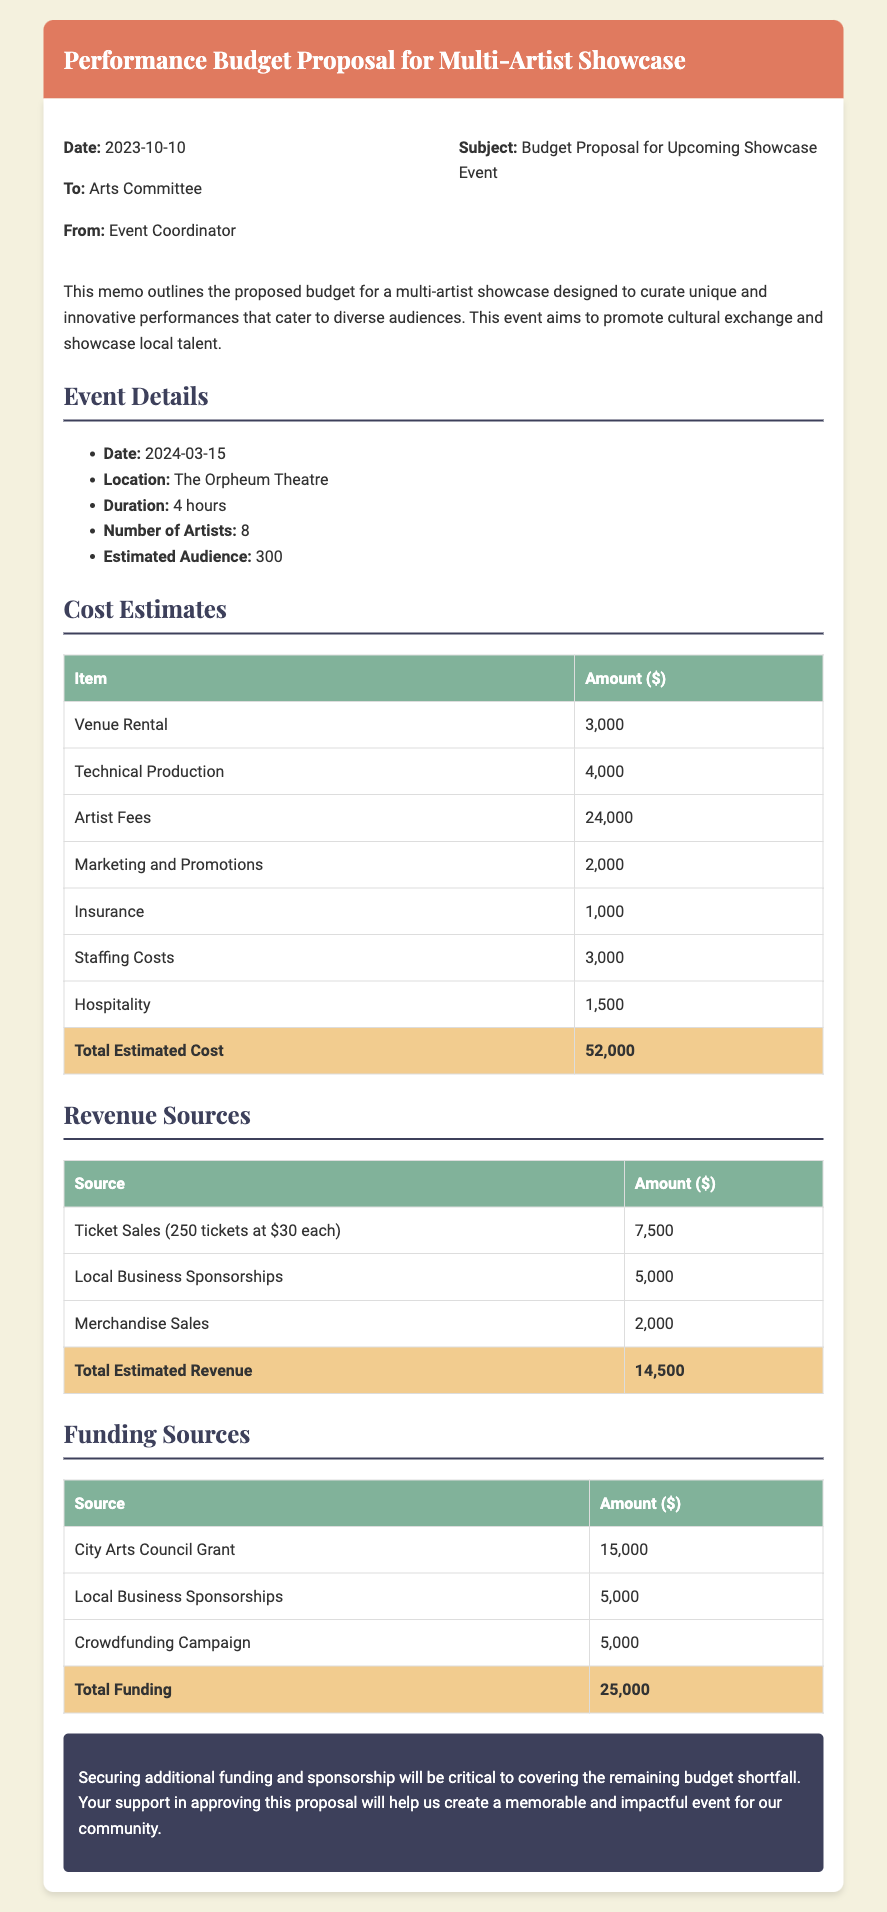what is the date of the event? The date of the event is explicitly listed in the document under the event details section.
Answer: 2024-03-15 how many artists are participating? The number of artists is mentioned in the event details as part of the showcase information.
Answer: 8 what is the total estimated cost? The total estimated cost is provided in the cost estimates table at the bottom of the section.
Answer: 52,000 what is the amount from ticket sales? The amount from ticket sales can be found in the revenue sources table, specifying ticket sales income.
Answer: 7,500 what is the total funding? The total funding is summarized in the funding sources table, giving a clear total amount for funding.
Answer: 25,000 how much is allocated for artist fees? The artist fees are specifically listed in the cost estimates table among the expense items.
Answer: 24,000 what is the main purpose of the event? The purpose of the event is described in the introductory paragraph of the memo.
Answer: Promote cultural exchange what is the venue for the event? The venue is mentioned in the event details section and specifies the location for the showcase.
Answer: The Orpheum Theatre what is the estimated audience size? The estimated audience size is provided under the event details, giving an idea of expected attendance.
Answer: 300 